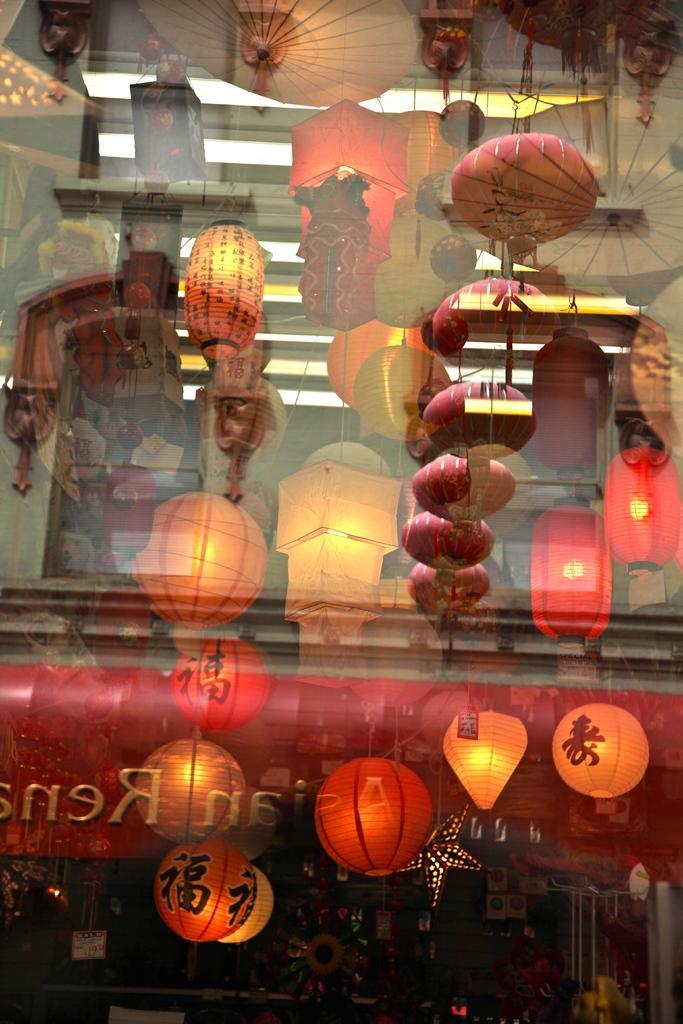In one or two sentences, can you explain what this image depicts? In this image there is a glass. Behind the glass we can see the decorative lamps and objects. 